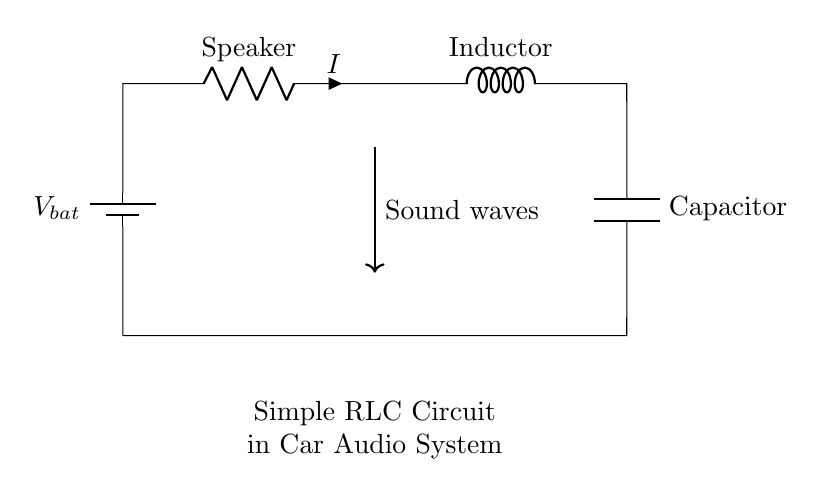What is the power source for this circuit? The circuit uses a battery as its power source, which is depicted on the left side labeled as V_bat.
Answer: battery What is the function of the inductor in this circuit? The inductor stores energy in a magnetic field when current flows through it and helps filter signals, which is vital for sound quality in audio systems.
Answer: filter What components are connected in series in this circuit? The speaker, inductor, and capacitor are connected in series, meaning they share the same current flowing through them.
Answer: speaker, inductor, capacitor What is the purpose of the capacitor in this circuit? The capacitor smoothens voltage fluctuations and helps to improve sound quality by filtering unwanted frequencies.
Answer: improve sound quality What type of circuit is represented in the diagram? The diagram represents a simple RLC circuit, as it includes a resistor (speaker), inductor, and capacitor specifically designed for audio applications.
Answer: RLC circuit What does the arrow denote in the diagram? The arrow shows the direction of sound waves produced by the circuit, indicating the output of the audio signal.
Answer: sound waves What happens to the sound when the RLC components are adjusted? Adjusting the resistance, inductance, or capacitance can change the frequency response of the audio system, altering the sound quality or tone.
Answer: alters sound quality 